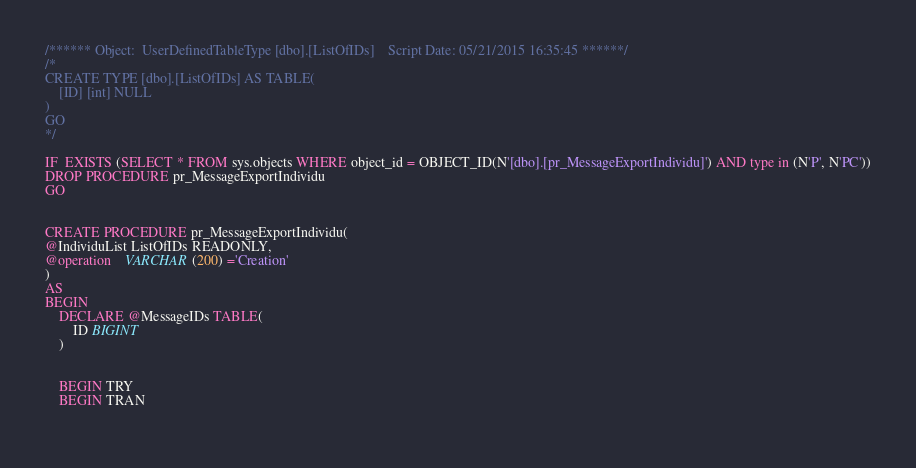Convert code to text. <code><loc_0><loc_0><loc_500><loc_500><_SQL_>


/****** Object:  UserDefinedTableType [dbo].[ListOfIDs]    Script Date: 05/21/2015 16:35:45 ******/
/*
CREATE TYPE [dbo].[ListOfIDs] AS TABLE(
	[ID] [int] NULL
)
GO
*/

IF  EXISTS (SELECT * FROM sys.objects WHERE object_id = OBJECT_ID(N'[dbo].[pr_MessageExportIndividu]') AND type in (N'P', N'PC'))
DROP PROCEDURE pr_MessageExportIndividu
GO


CREATE PROCEDURE pr_MessageExportIndividu(
@IndividuList ListOfIDs READONLY,
@operation	VARCHAR(200) ='Creation'
)
AS
BEGIN
	DECLARE @MessageIDs TABLE(
		ID BIGINT
	)


	BEGIN TRY
	BEGIN TRAN
	</code> 